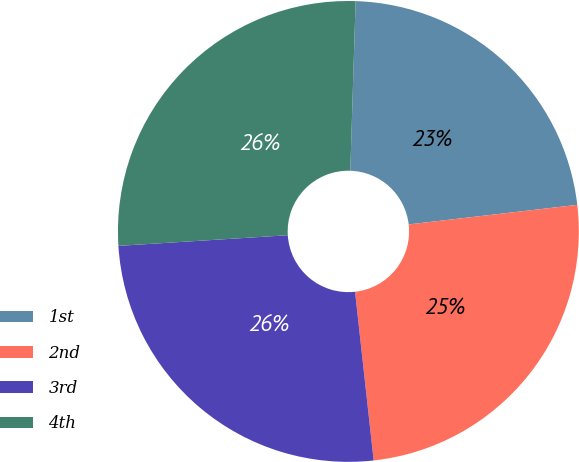<chart> <loc_0><loc_0><loc_500><loc_500><pie_chart><fcel>1st<fcel>2nd<fcel>3rd<fcel>4th<nl><fcel>22.66%<fcel>25.09%<fcel>25.75%<fcel>26.5%<nl></chart> 